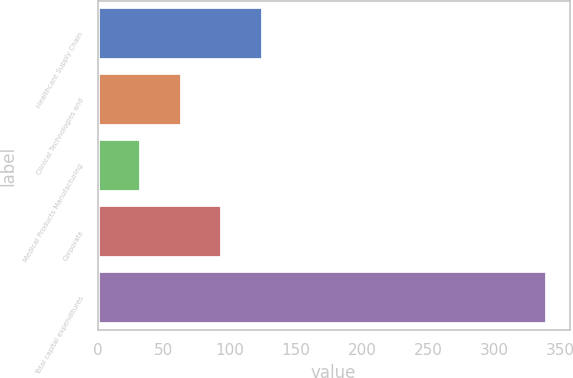<chart> <loc_0><loc_0><loc_500><loc_500><bar_chart><fcel>Healthcare Supply Chain<fcel>Clinical Technologies and<fcel>Medical Products Manufacturing<fcel>Corporate<fcel>Total capital expenditures<nl><fcel>124.93<fcel>63.51<fcel>32.8<fcel>94.22<fcel>339.9<nl></chart> 